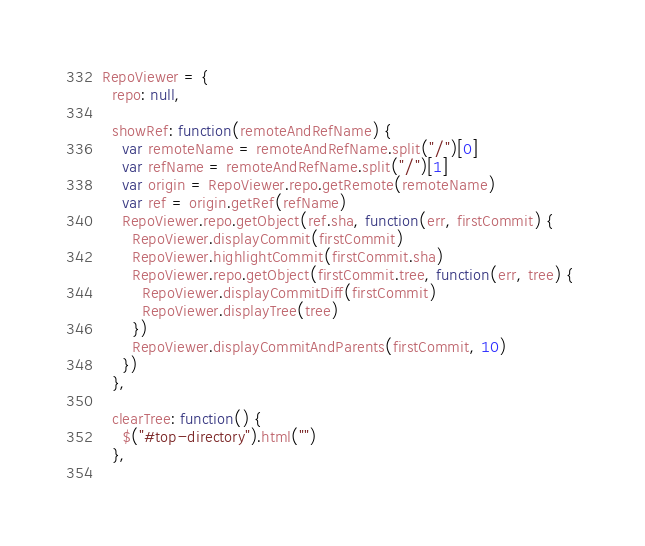Convert code to text. <code><loc_0><loc_0><loc_500><loc_500><_JavaScript_>
RepoViewer = {
  repo: null,
  
  showRef: function(remoteAndRefName) {
    var remoteName = remoteAndRefName.split("/")[0]
    var refName = remoteAndRefName.split("/")[1]
    var origin = RepoViewer.repo.getRemote(remoteName)
    var ref = origin.getRef(refName)
    RepoViewer.repo.getObject(ref.sha, function(err, firstCommit) {
      RepoViewer.displayCommit(firstCommit)
      RepoViewer.highlightCommit(firstCommit.sha)
      RepoViewer.repo.getObject(firstCommit.tree, function(err, tree) { 
        RepoViewer.displayCommitDiff(firstCommit)
        RepoViewer.displayTree(tree) 
      })
      RepoViewer.displayCommitAndParents(firstCommit, 10)
    })
  },
  
  clearTree: function() {
    $("#top-directory").html("")
  },
  </code> 